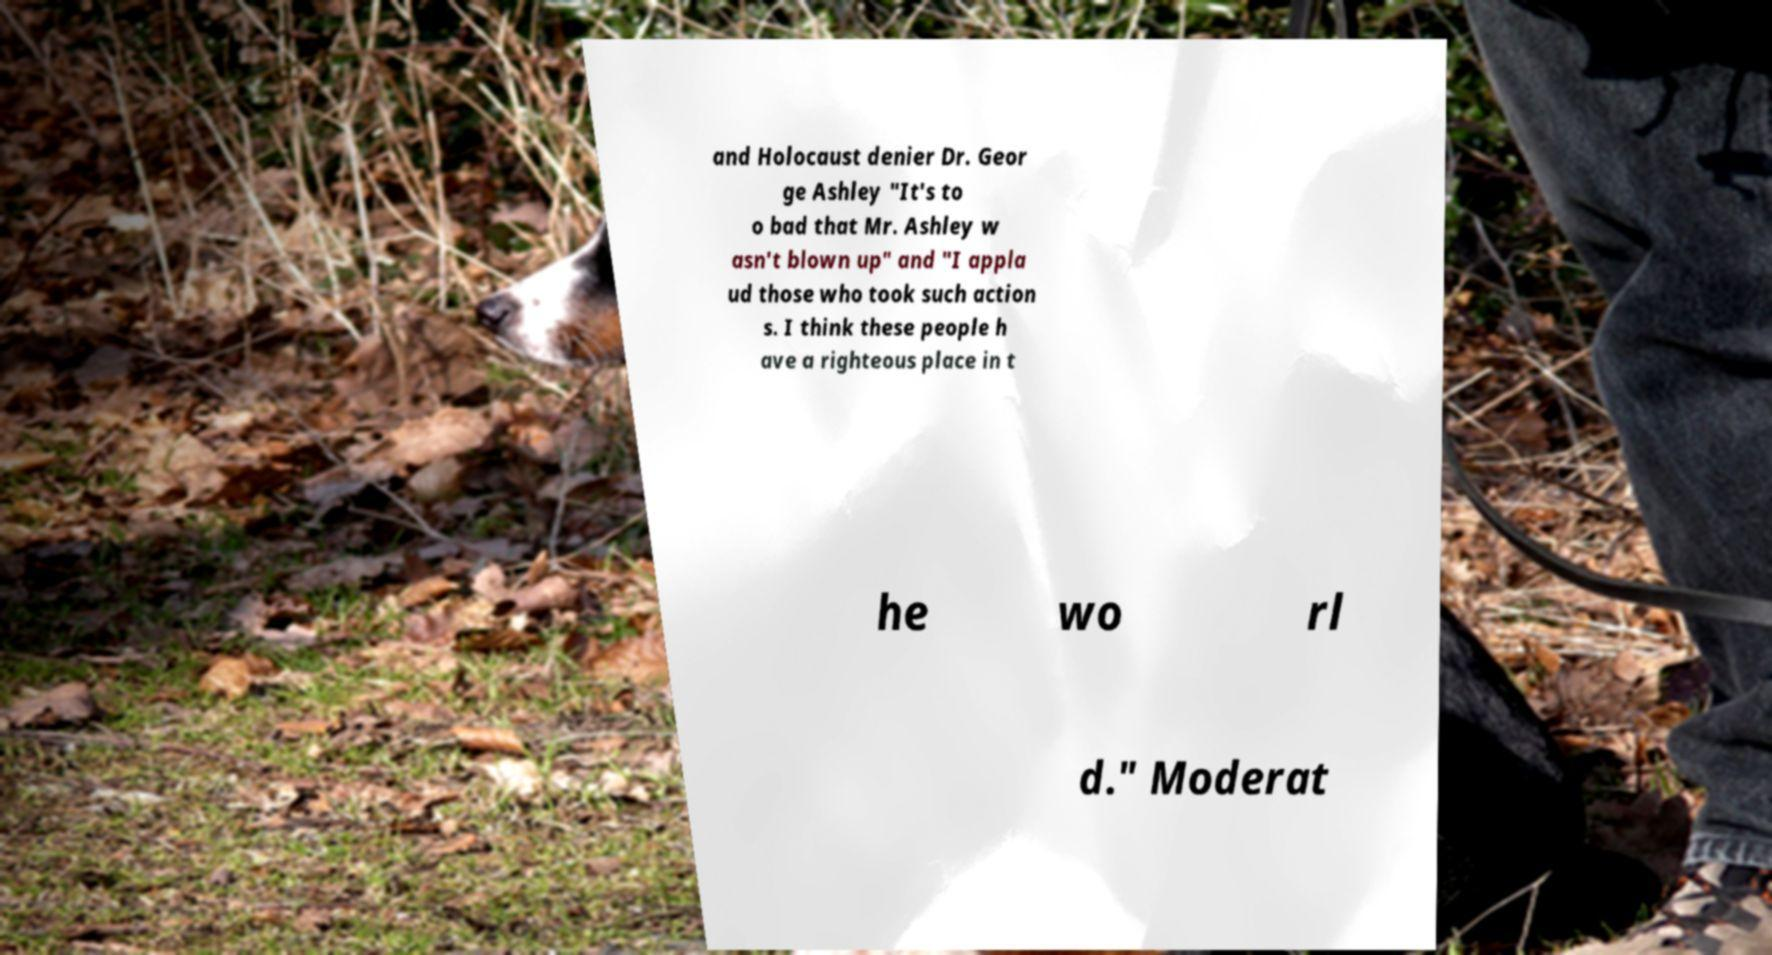Can you accurately transcribe the text from the provided image for me? and Holocaust denier Dr. Geor ge Ashley "It's to o bad that Mr. Ashley w asn't blown up" and "I appla ud those who took such action s. I think these people h ave a righteous place in t he wo rl d." Moderat 